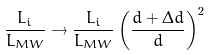Convert formula to latex. <formula><loc_0><loc_0><loc_500><loc_500>\frac { L _ { i } } { L _ { M W } } \rightarrow \frac { L _ { i } } { L _ { M W } } \left ( \frac { d + \Delta d } { d } \right ) ^ { 2 }</formula> 